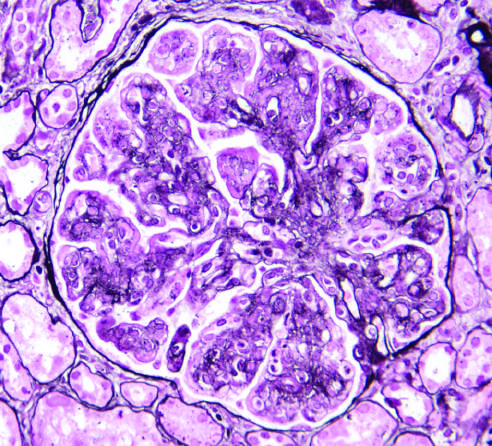what shows mesangial cell proliferation, basement membrane duplication, leukocyte infiltration, and accentuation of lobular architecture?
Answer the question using a single word or phrase. Membranoproliferative glomerulonephritis (mpgn) 